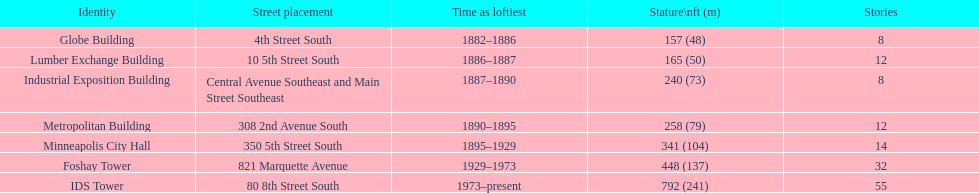What was the first building named as the tallest? Globe Building. 